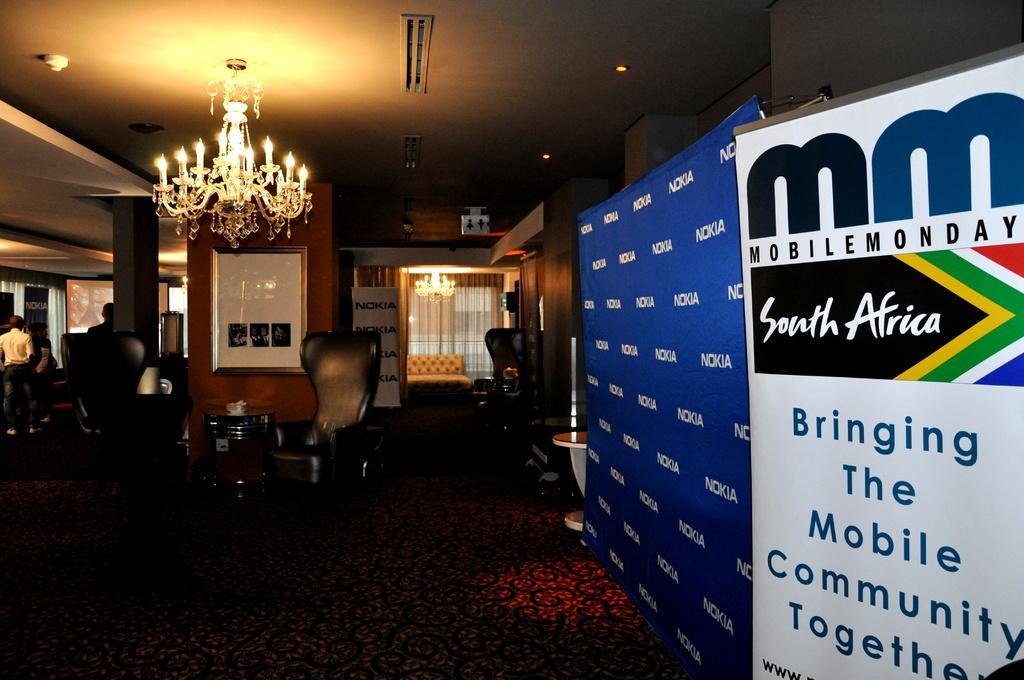Can you describe this image briefly? In the picture we can see a hotel room with some hoardings kept on the stand and in the background, we can see some chairs near the wall with a cupboard which is white in color and besides, we can see some people sitting on the chairs and to the ceiling we can see a candle stand with candles and to the floor we can see a floor mat which is red in color. 